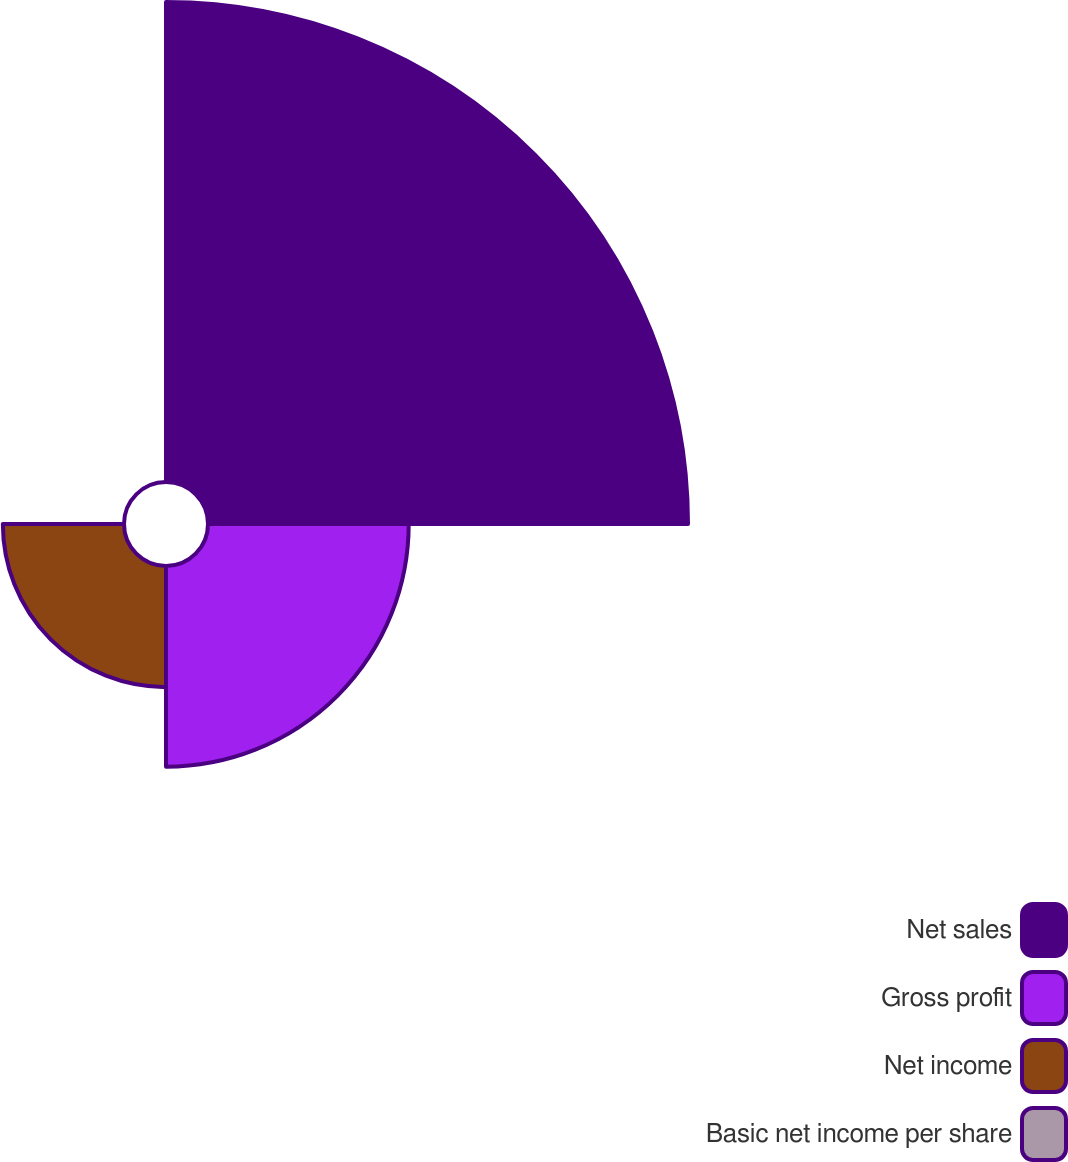Convert chart. <chart><loc_0><loc_0><loc_500><loc_500><pie_chart><fcel>Net sales<fcel>Gross profit<fcel>Net income<fcel>Basic net income per share<nl><fcel>59.86%<fcel>25.03%<fcel>15.11%<fcel>0.0%<nl></chart> 